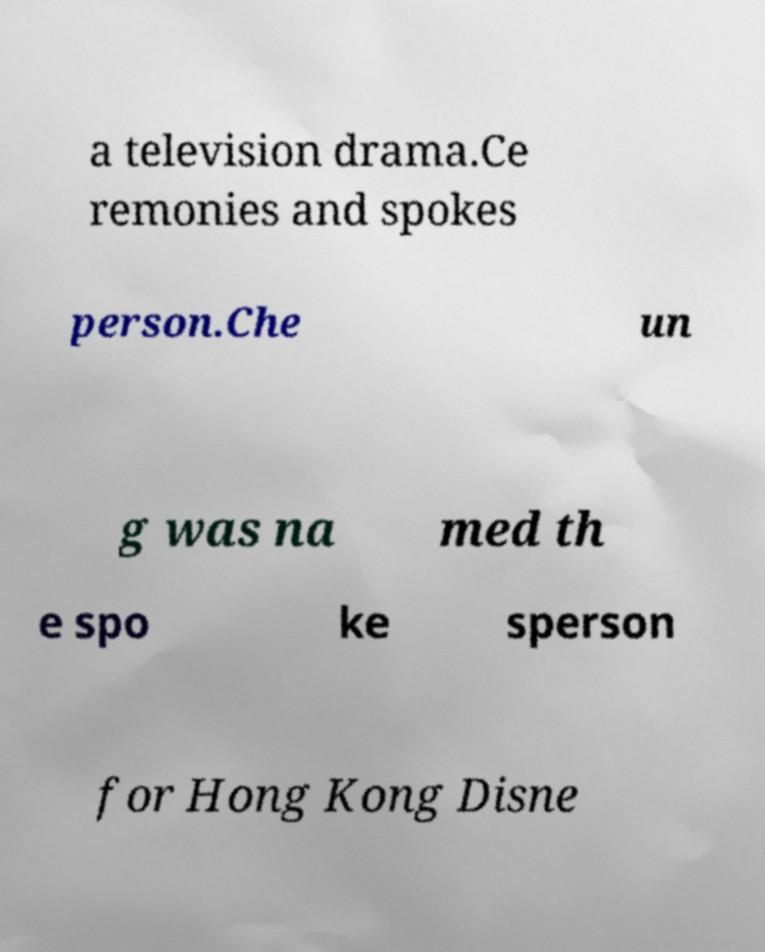Could you assist in decoding the text presented in this image and type it out clearly? a television drama.Ce remonies and spokes person.Che un g was na med th e spo ke sperson for Hong Kong Disne 